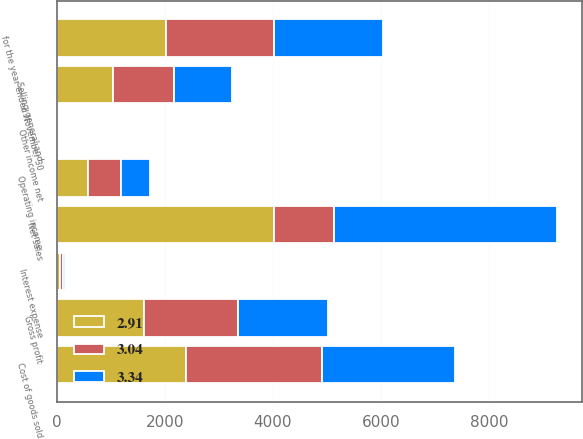Convert chart. <chart><loc_0><loc_0><loc_500><loc_500><stacked_bar_chart><ecel><fcel>for the year ended November 30<fcel>Net sales<fcel>Cost of goods sold<fcel>Gross profit<fcel>Selling general and<fcel>Operating income<fcel>Interest expense<fcel>Other income net<nl><fcel>3.04<fcel>2014<fcel>1122<fcel>2513<fcel>1730.2<fcel>1122<fcel>603<fcel>49.7<fcel>1.1<nl><fcel>3.34<fcel>2013<fcel>4123.4<fcel>2457.6<fcel>1665.8<fcel>1075<fcel>550.5<fcel>53.3<fcel>2.2<nl><fcel>2.91<fcel>2012<fcel>4014.2<fcel>2396.4<fcel>1617.8<fcel>1039.5<fcel>578.3<fcel>54.6<fcel>2.4<nl></chart> 